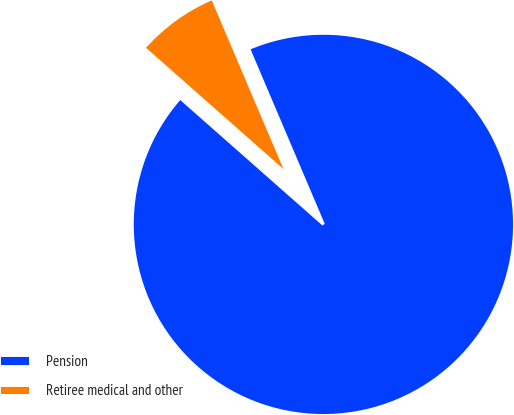<chart> <loc_0><loc_0><loc_500><loc_500><pie_chart><fcel>Pension<fcel>Retiree medical and other<nl><fcel>92.9%<fcel>7.1%<nl></chart> 